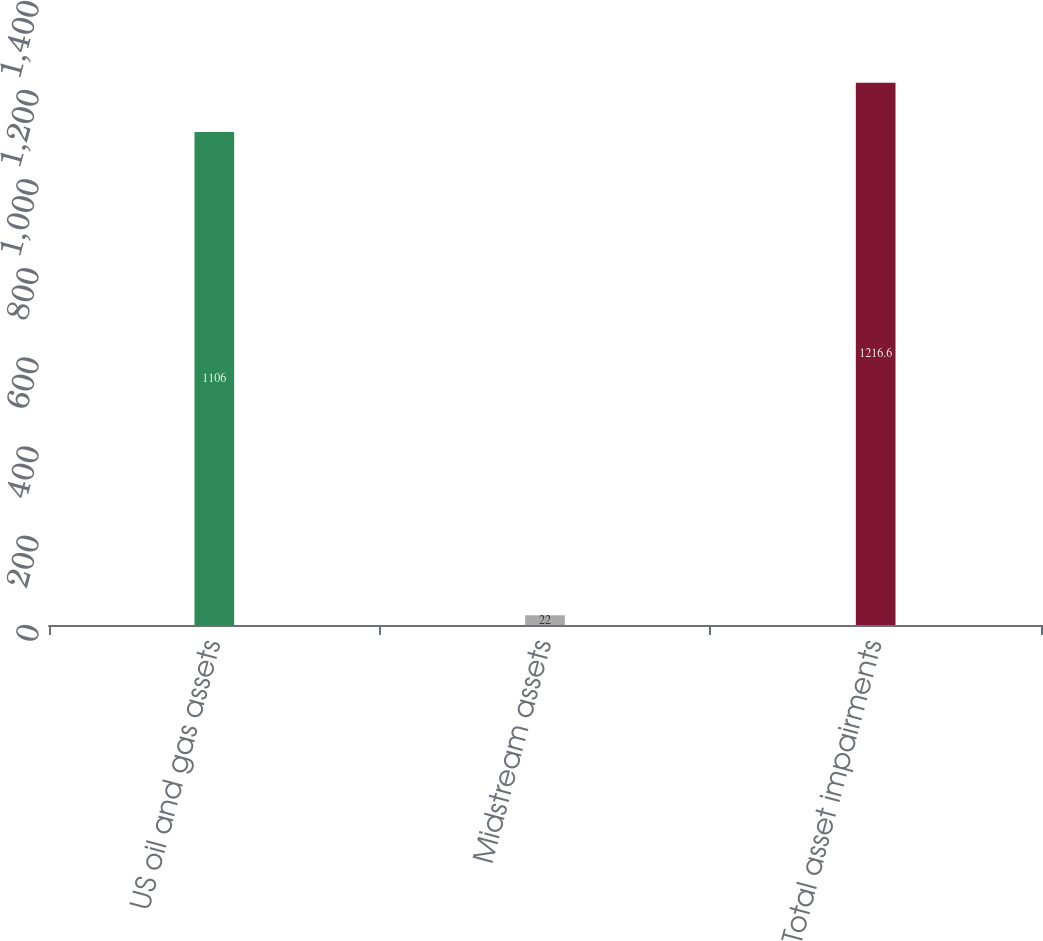Convert chart to OTSL. <chart><loc_0><loc_0><loc_500><loc_500><bar_chart><fcel>US oil and gas assets<fcel>Midstream assets<fcel>Total asset impairments<nl><fcel>1106<fcel>22<fcel>1216.6<nl></chart> 